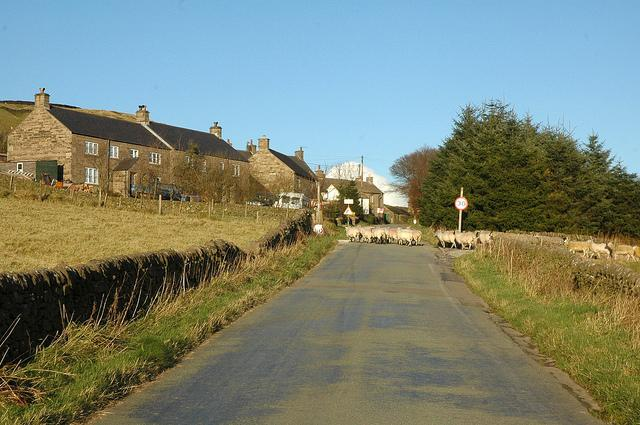When travelling this road for safety what should you allow to cross first? sheep 